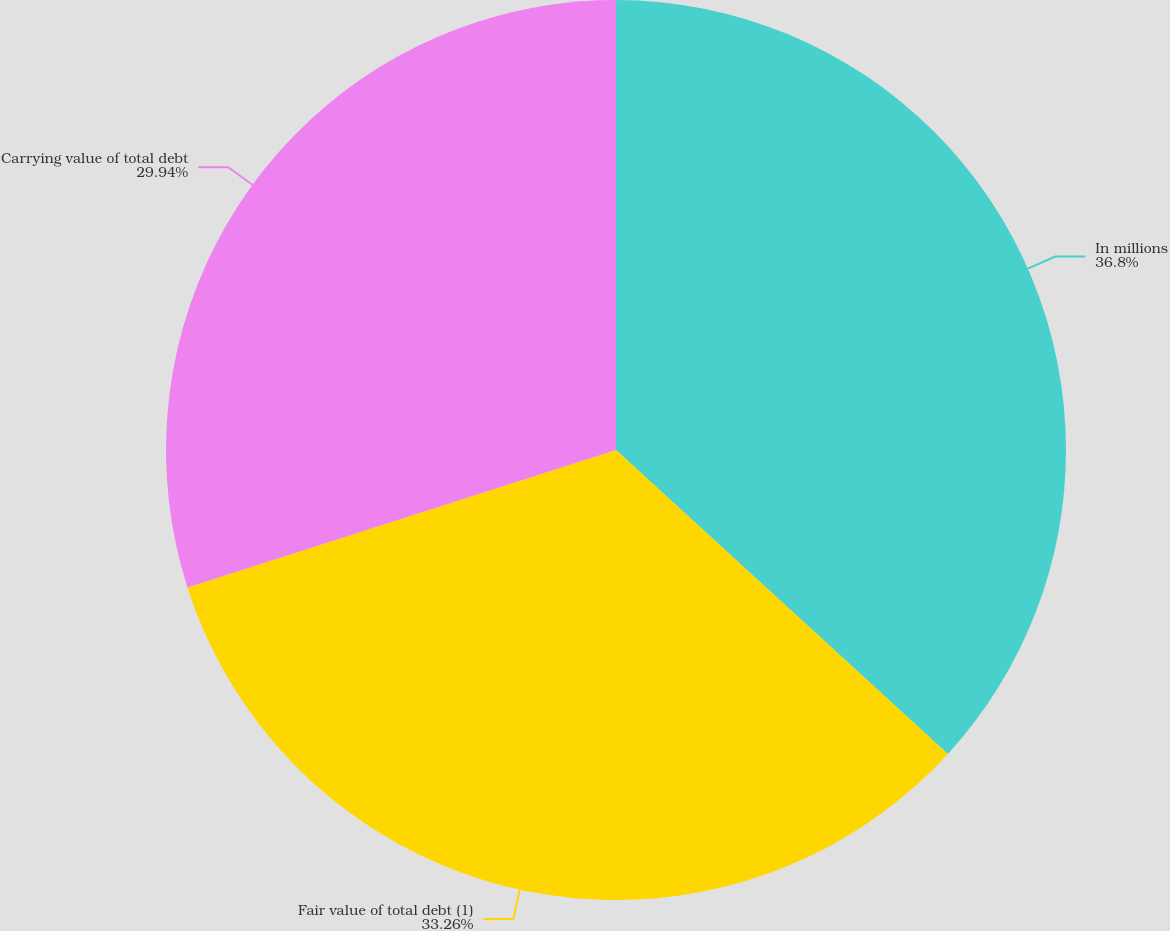Convert chart. <chart><loc_0><loc_0><loc_500><loc_500><pie_chart><fcel>In millions<fcel>Fair value of total debt (1)<fcel>Carrying value of total debt<nl><fcel>36.8%<fcel>33.26%<fcel>29.94%<nl></chart> 